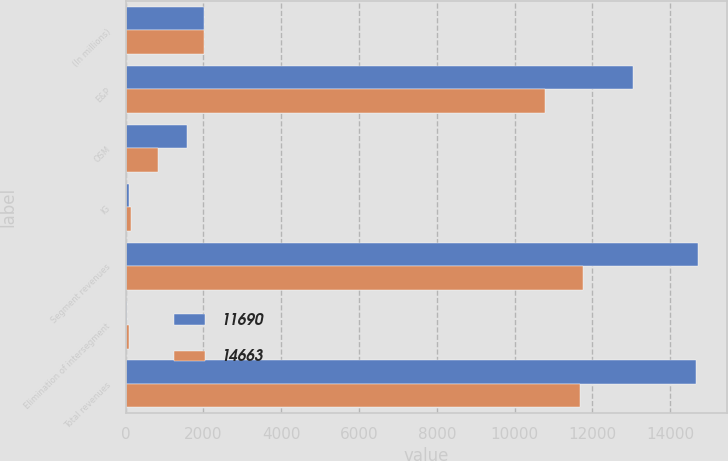<chart> <loc_0><loc_0><loc_500><loc_500><stacked_bar_chart><ecel><fcel>(In millions)<fcel>E&P<fcel>OSM<fcel>IG<fcel>Segment revenues<fcel>Elimination of intersegment<fcel>Total revenues<nl><fcel>11690<fcel>2011<fcel>13029<fcel>1588<fcel>93<fcel>14710<fcel>47<fcel>14663<nl><fcel>14663<fcel>2010<fcel>10782<fcel>833<fcel>150<fcel>11765<fcel>75<fcel>11690<nl></chart> 